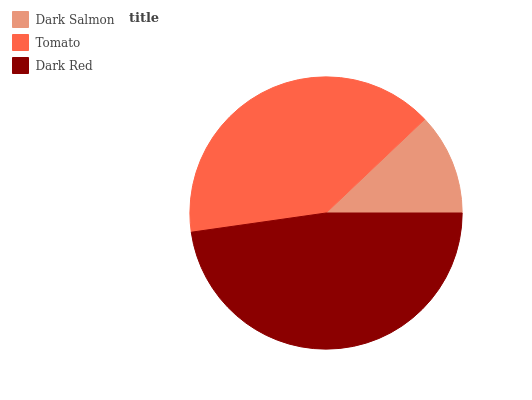Is Dark Salmon the minimum?
Answer yes or no. Yes. Is Dark Red the maximum?
Answer yes or no. Yes. Is Tomato the minimum?
Answer yes or no. No. Is Tomato the maximum?
Answer yes or no. No. Is Tomato greater than Dark Salmon?
Answer yes or no. Yes. Is Dark Salmon less than Tomato?
Answer yes or no. Yes. Is Dark Salmon greater than Tomato?
Answer yes or no. No. Is Tomato less than Dark Salmon?
Answer yes or no. No. Is Tomato the high median?
Answer yes or no. Yes. Is Tomato the low median?
Answer yes or no. Yes. Is Dark Salmon the high median?
Answer yes or no. No. Is Dark Salmon the low median?
Answer yes or no. No. 